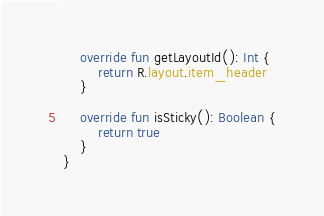Convert code to text. <code><loc_0><loc_0><loc_500><loc_500><_Kotlin_>
    override fun getLayoutId(): Int {
        return R.layout.item_header
    }

    override fun isSticky(): Boolean {
        return true
    }
}</code> 